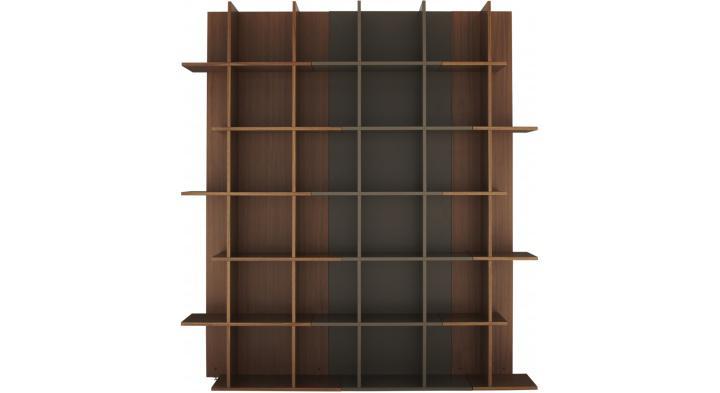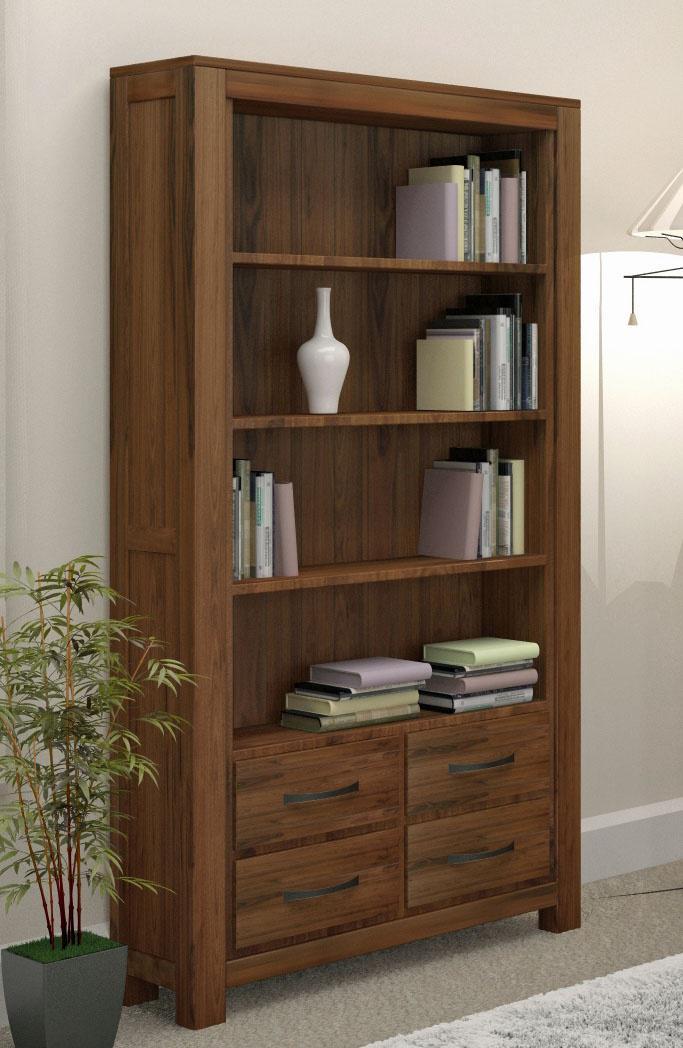The first image is the image on the left, the second image is the image on the right. Assess this claim about the two images: "There are exactly two empty bookcases.". Correct or not? Answer yes or no. No. The first image is the image on the left, the second image is the image on the right. Examine the images to the left and right. Is the description "One brown bookcase has a grid of same-size square compartments, and the other brown bookcase has closed-front storage at the bottom." accurate? Answer yes or no. Yes. 